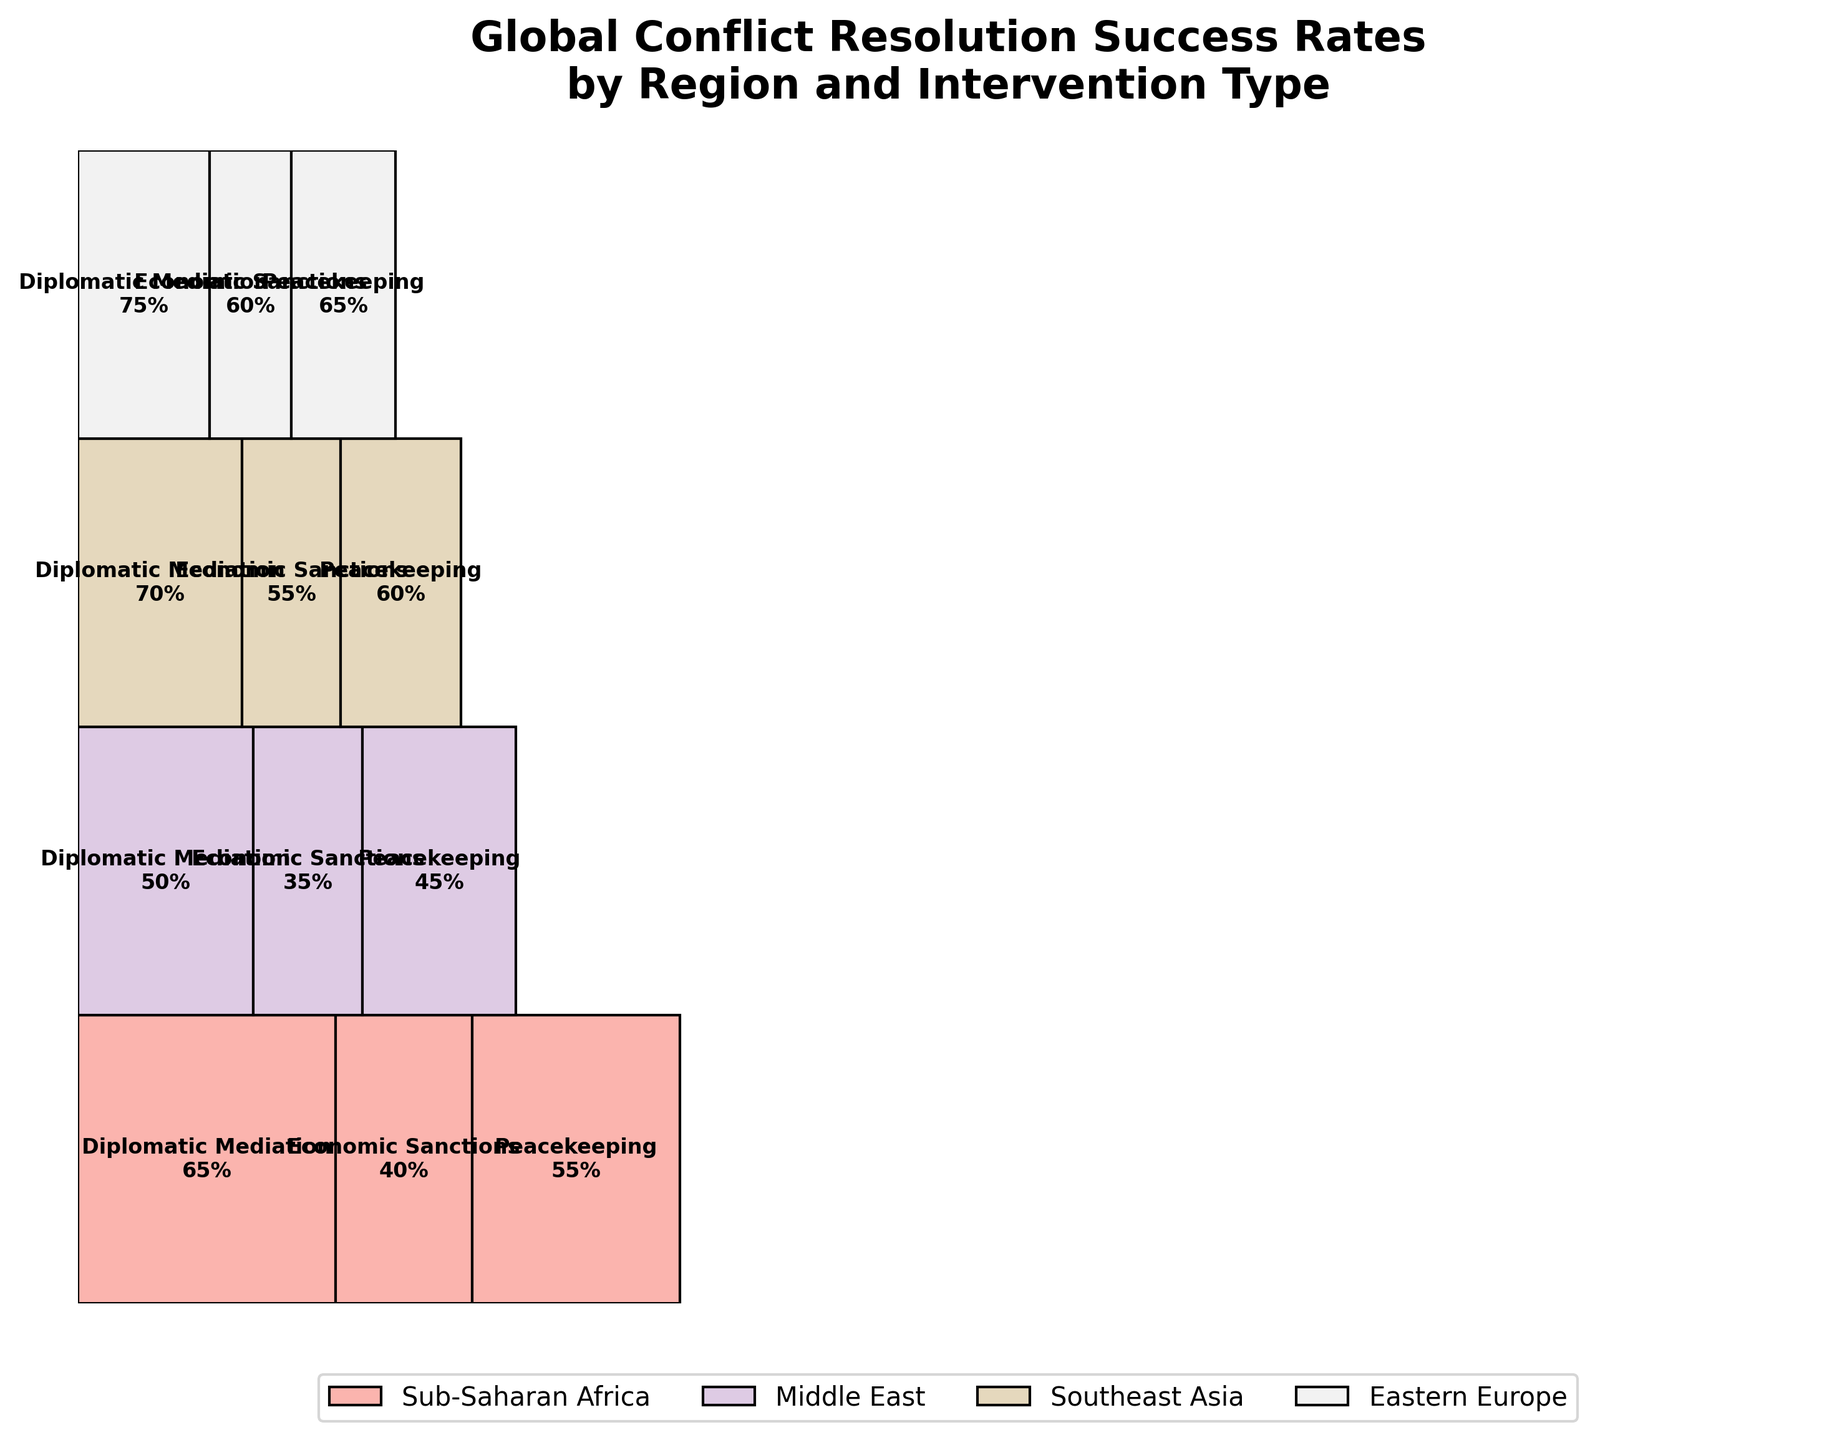What is the title of the figure? Look at the top of the figure to identify the text that summarizes the main topic.
Answer: Global Conflict Resolution Success Rates by Region and Intervention Type How many regions are represented in the figure? Count the unique regions listed in the legend at the bottom.
Answer: 4 Which intervention type has the highest success rate in Southeast Asia? Locate the section for Southeast Asia, look for the intervention type with the highest percentage indicated.
Answer: Diplomatic Mediation Which region has the highest success rate for Peacekeeping? Find and compare the Peacekeeping success rates for each region.
Answer: Eastern Europe Compare the success rates of Economic Sanctions in Sub-Saharan Africa and Southeast Asia. Which is higher? Look at the Economic Sanctions sections for both regions and compare their success rates.
Answer: Southeast Asia What is the combined total number of cases for Diplomatic Mediation and Peacekeeping in the Middle East? Add the number of cases for Diplomatic Mediation and Peacekeeping in the Middle East.
Answer: 60 Which region has more cases of Economic Sanctions, Middle East or Eastern Europe? Compare the number of cases for Economic Sanctions between the Middle East and Eastern Europe.
Answer: Middle East What is the overall success rate for interventions in Eastern Europe? Calculate the average success rate for all intervention types in Eastern Europe. (75% + 60% + 65%) / 3 = 200% / 3
Answer: 66.67% Is Diplomatic Mediation generally more successful than Economic Sanctions across all regions? Compare the success rates of Diplomatic Mediation and Economic Sanctions in each region to determine the general trend.
Answer: Yes 